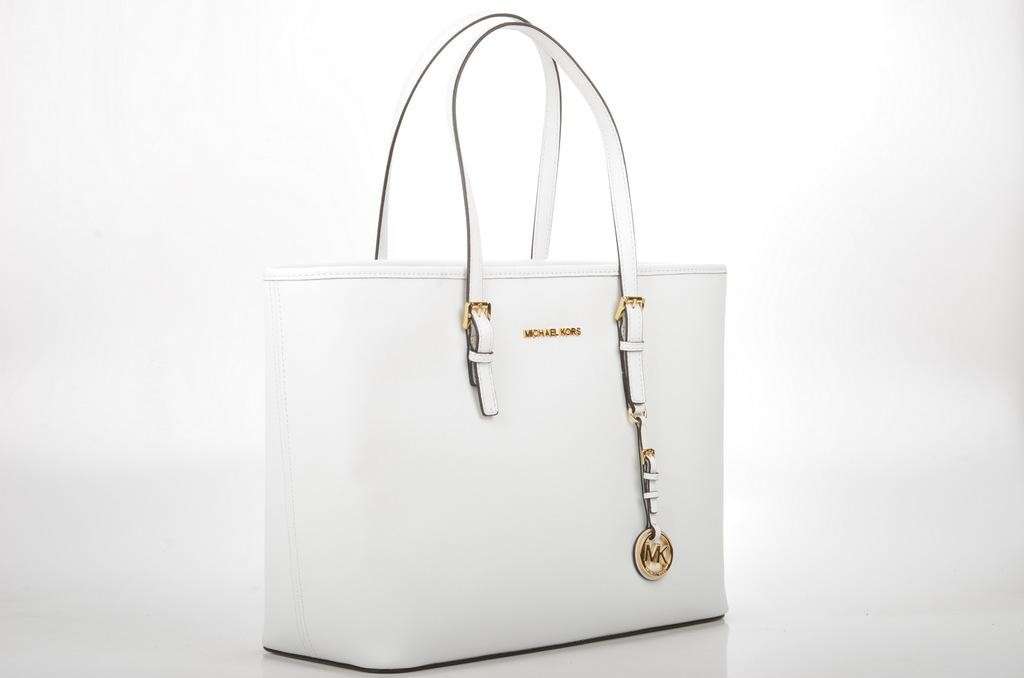What object is present in the image that might be used for carrying items? There is a bag in the image. What is the color of the bag in the image? The bag is white in color. What type of milk is being requested by the bag in the image? There is no milk or request present in the image; it only features a white bag. What type of seed is visible growing from the bag in the image? There is no seed present in the image; it only features a white bag. 